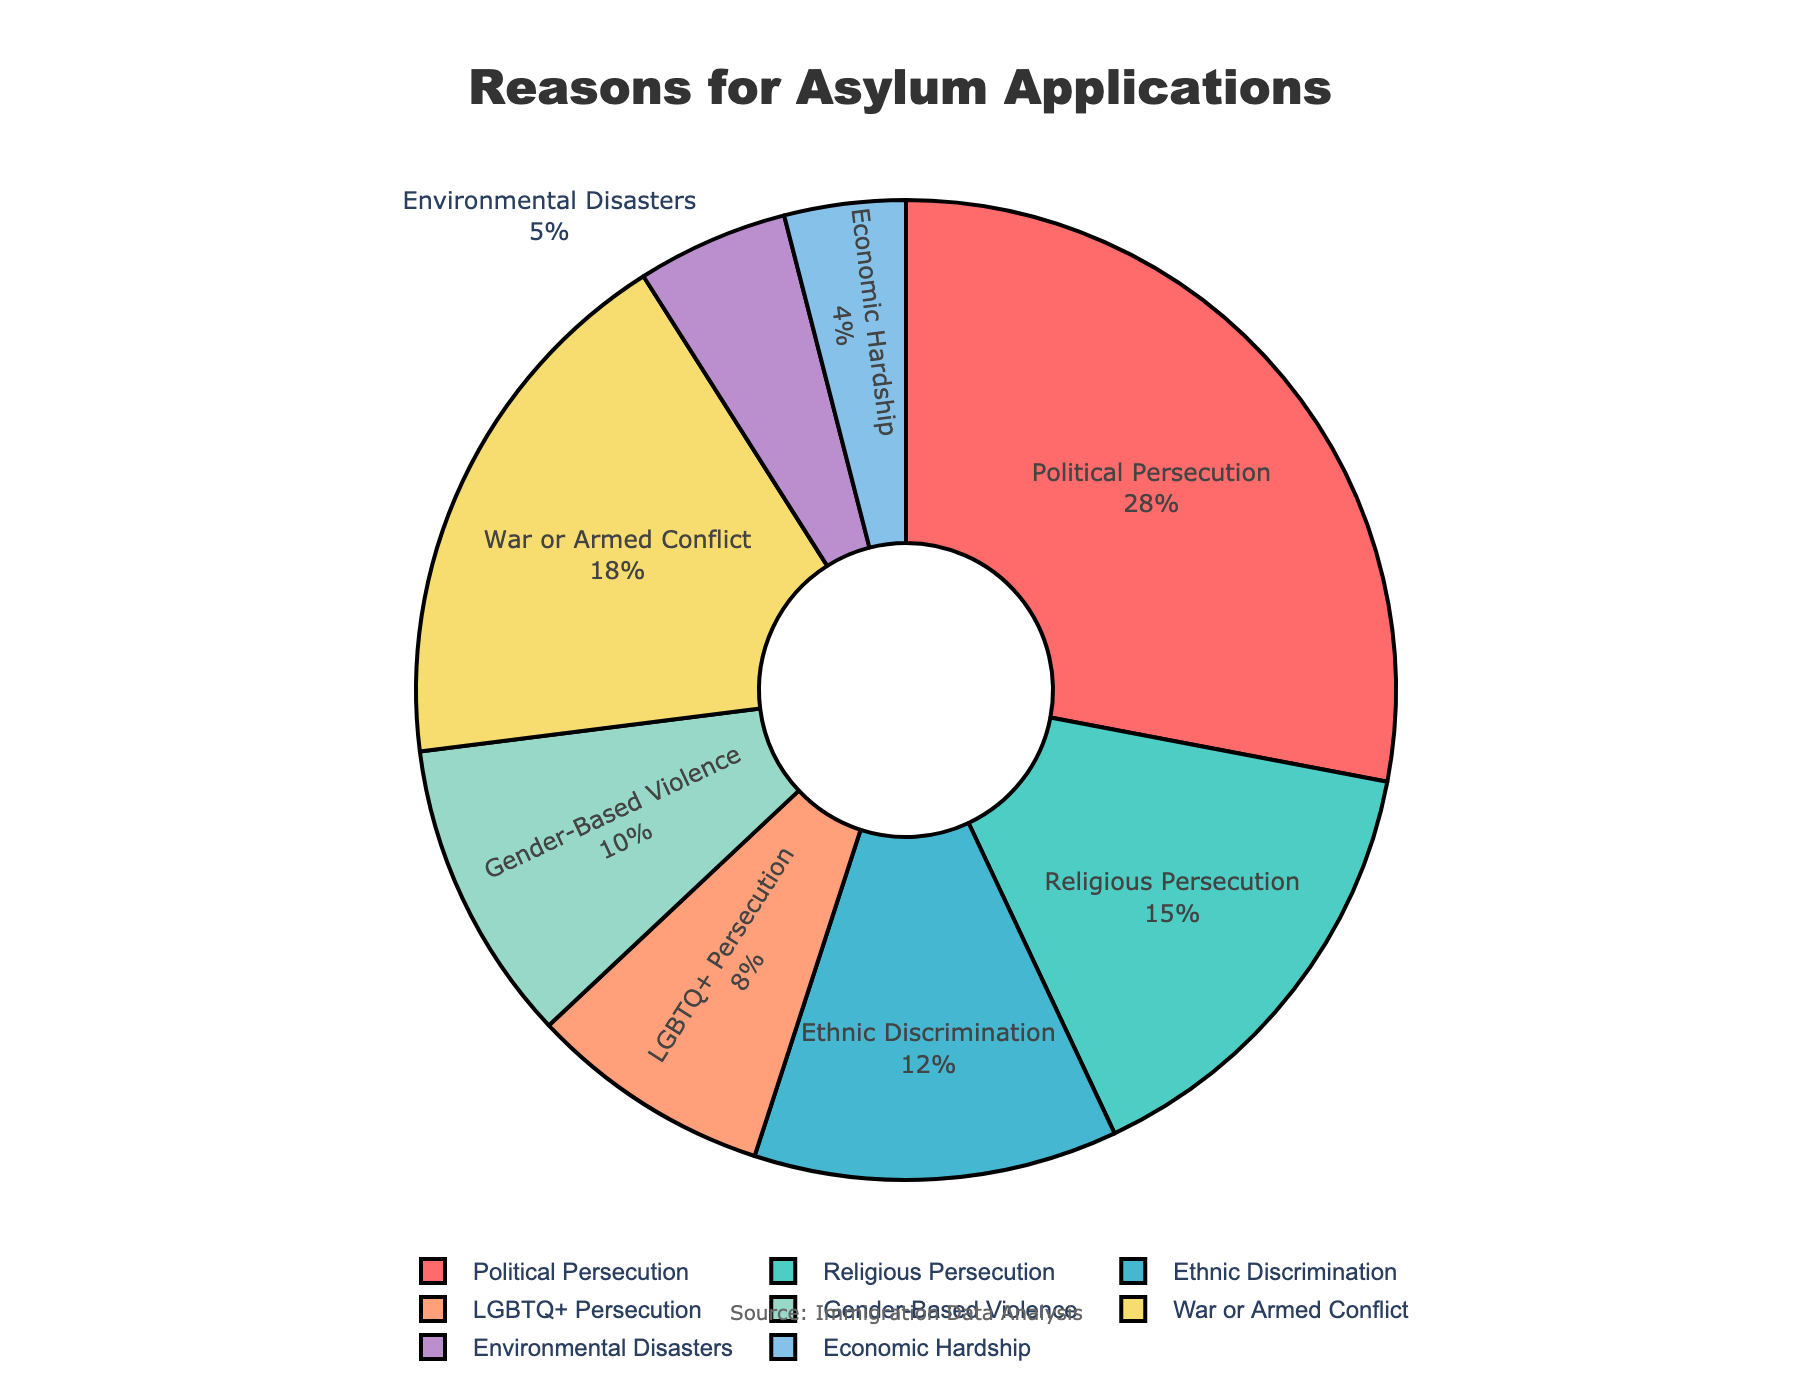What's the largest category for asylum applications? The largest category is the one with the highest percentage. From the pie chart, Political Persecution has 28%.
Answer: Political Persecution What's the combined percentage of asylum applications for Political Persecution and War or Armed Conflict? Add the percentage of Political Persecution (28%) to the percentage of War or Armed Conflict (18%). 28% + 18% = 46%
Answer: 46% How much higher is the percentage for Gender-Based Violence compared to Economic Hardship? Subtract the percentage of Economic Hardship (4%) from Gender-Based Violence (10%). 10% - 4% = 6%
Answer: 6% Which category has the smallest percentage of asylum applications? The smallest slice of the pie chart corresponds to Economic Hardship with 4%.
Answer: Economic Hardship What is the percentage difference between Religious Persecution and LGBTQ+ Persecution? Subtract the percentage of LGBTQ+ Persecution (8%) from Religious Persecution (15%). 15% - 8% = 7%
Answer: 7% Which categories have a percentage above 20%? From the pie chart, only Political Persecution has a percentage above 20% with 28%.
Answer: Political Persecution What is the total percentage of asylum applications for categories related to persecution (Political, Religious, Ethnic, LGBTQ+)? Sum up the percentages: Political Persecution (28%) + Religious Persecution (15%) + Ethnic Discrimination (12%) + LGBTQ+ Persecution (8%). 28% + 15% + 12% + 8% = 63%
Answer: 63% By how much does War or Armed Conflict exceed Environmental Disasters in the percentage of asylum applications? Subtract the percentage of Environmental Disasters (5%) from War or Armed Conflict (18%). 18% - 5% = 13%
Answer: 13% What color represents the category with the third largest percentage? The third largest percentage is Ethnic Discrimination (12%), which is represented by the light blue color (fourth color in the pie chart which is "#45B7D1").
Answer: Light Blue What is the average percentage of applications for categories representing persecution (Political, Religious, Ethnic, LGBTQ+) and non-persecution-related reasons (Gender-Based, War, Environmental, Economic)? Calculate the average for persecution categories: (28% + 15% + 12% + 8%) / 4 = 63% / 4 = 15.75%. For non-persecution categories: (10% + 18% + 5% + 4%) / 4 = 37% / 4 = 9.25%.
Answer: Persecution: 15.75%, Non-persecution: 9.25% 